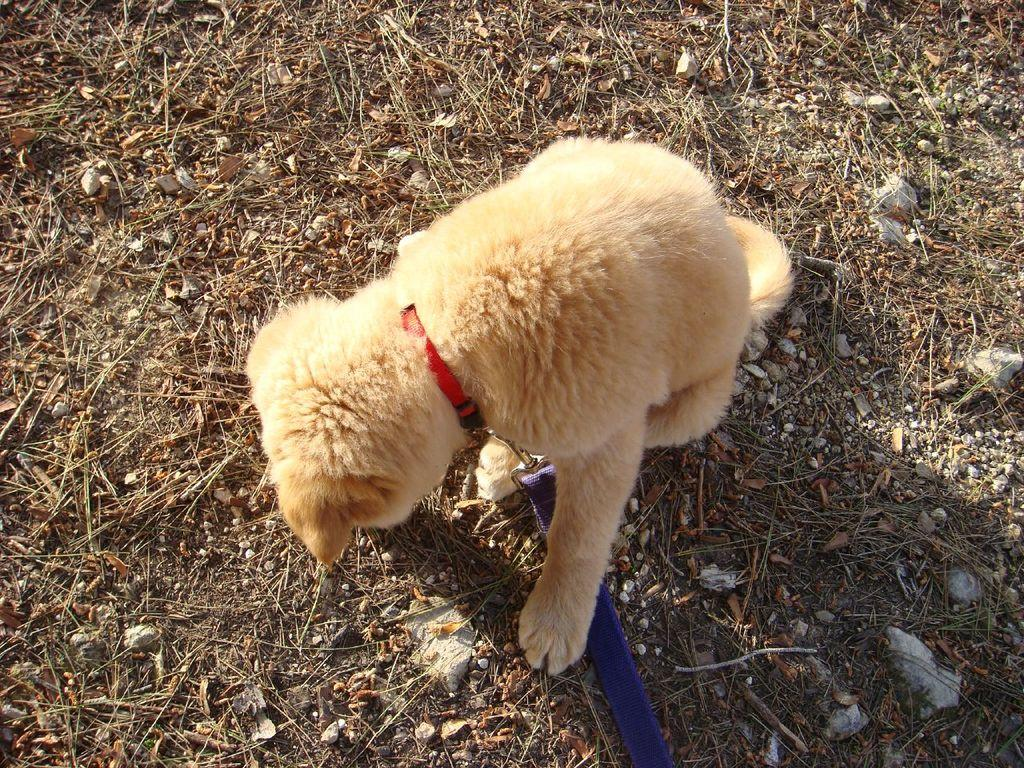What is the main subject in the center of the image? There is a puppy in the center of the image. What type of surface is visible at the bottom of the image? There is sand at the bottom of the image. What else can be seen at the bottom of the image? There are scraps and a belt at the bottom of the image. What decision does the monkey make in the image? There is no monkey present in the image, so it is not possible to determine any decisions made by a monkey. 